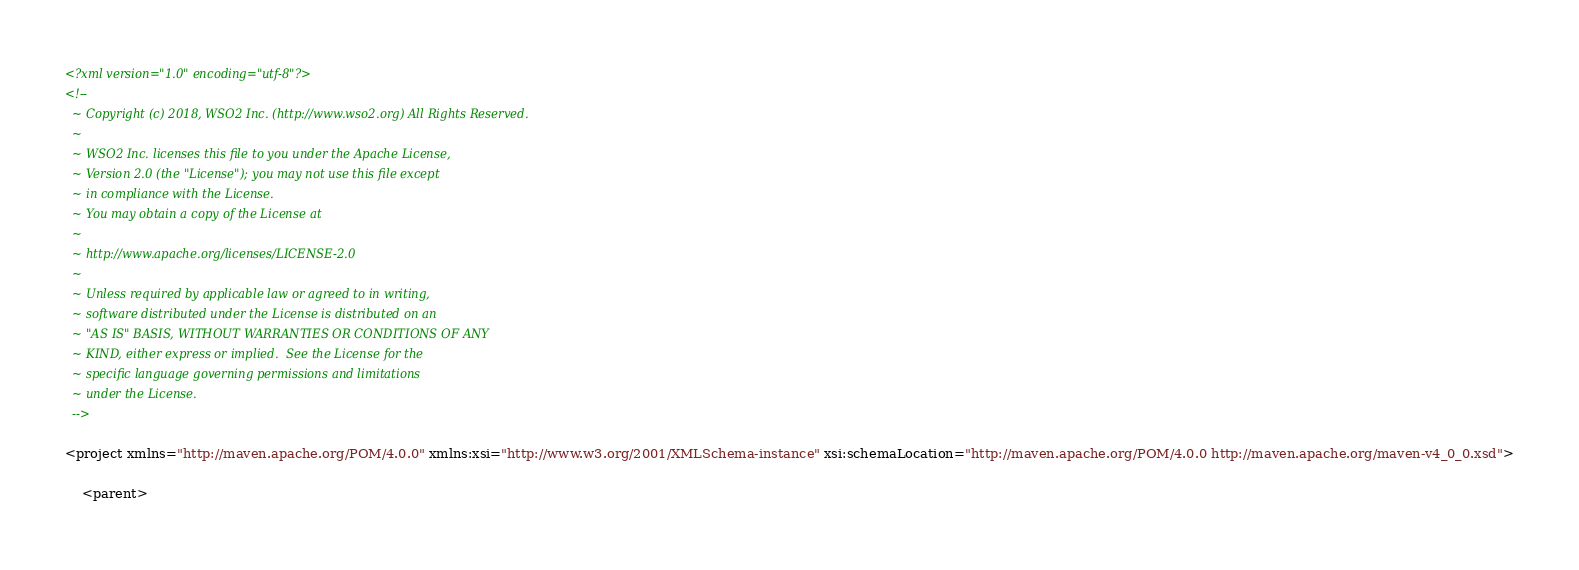<code> <loc_0><loc_0><loc_500><loc_500><_XML_><?xml version="1.0" encoding="utf-8"?>
<!--
  ~ Copyright (c) 2018, WSO2 Inc. (http://www.wso2.org) All Rights Reserved.
  ~
  ~ WSO2 Inc. licenses this file to you under the Apache License,
  ~ Version 2.0 (the "License"); you may not use this file except
  ~ in compliance with the License.
  ~ You may obtain a copy of the License at
  ~
  ~ http://www.apache.org/licenses/LICENSE-2.0
  ~
  ~ Unless required by applicable law or agreed to in writing,
  ~ software distributed under the License is distributed on an
  ~ "AS IS" BASIS, WITHOUT WARRANTIES OR CONDITIONS OF ANY
  ~ KIND, either express or implied.  See the License for the
  ~ specific language governing permissions and limitations
  ~ under the License.
  -->

<project xmlns="http://maven.apache.org/POM/4.0.0" xmlns:xsi="http://www.w3.org/2001/XMLSchema-instance" xsi:schemaLocation="http://maven.apache.org/POM/4.0.0 http://maven.apache.org/maven-v4_0_0.xsd">

    <parent></code> 